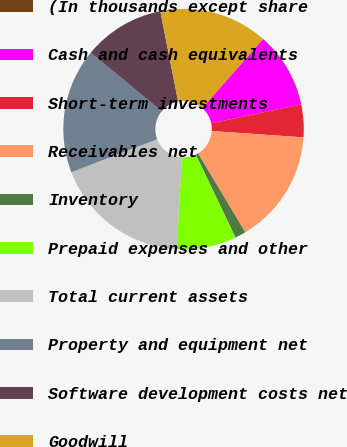Convert chart. <chart><loc_0><loc_0><loc_500><loc_500><pie_chart><fcel>(In thousands except share<fcel>Cash and cash equivalents<fcel>Short-term investments<fcel>Receivables net<fcel>Inventory<fcel>Prepaid expenses and other<fcel>Total current assets<fcel>Property and equipment net<fcel>Software development costs net<fcel>Goodwill<nl><fcel>0.0%<fcel>10.22%<fcel>4.38%<fcel>15.33%<fcel>1.46%<fcel>8.03%<fcel>18.25%<fcel>16.79%<fcel>10.95%<fcel>14.6%<nl></chart> 